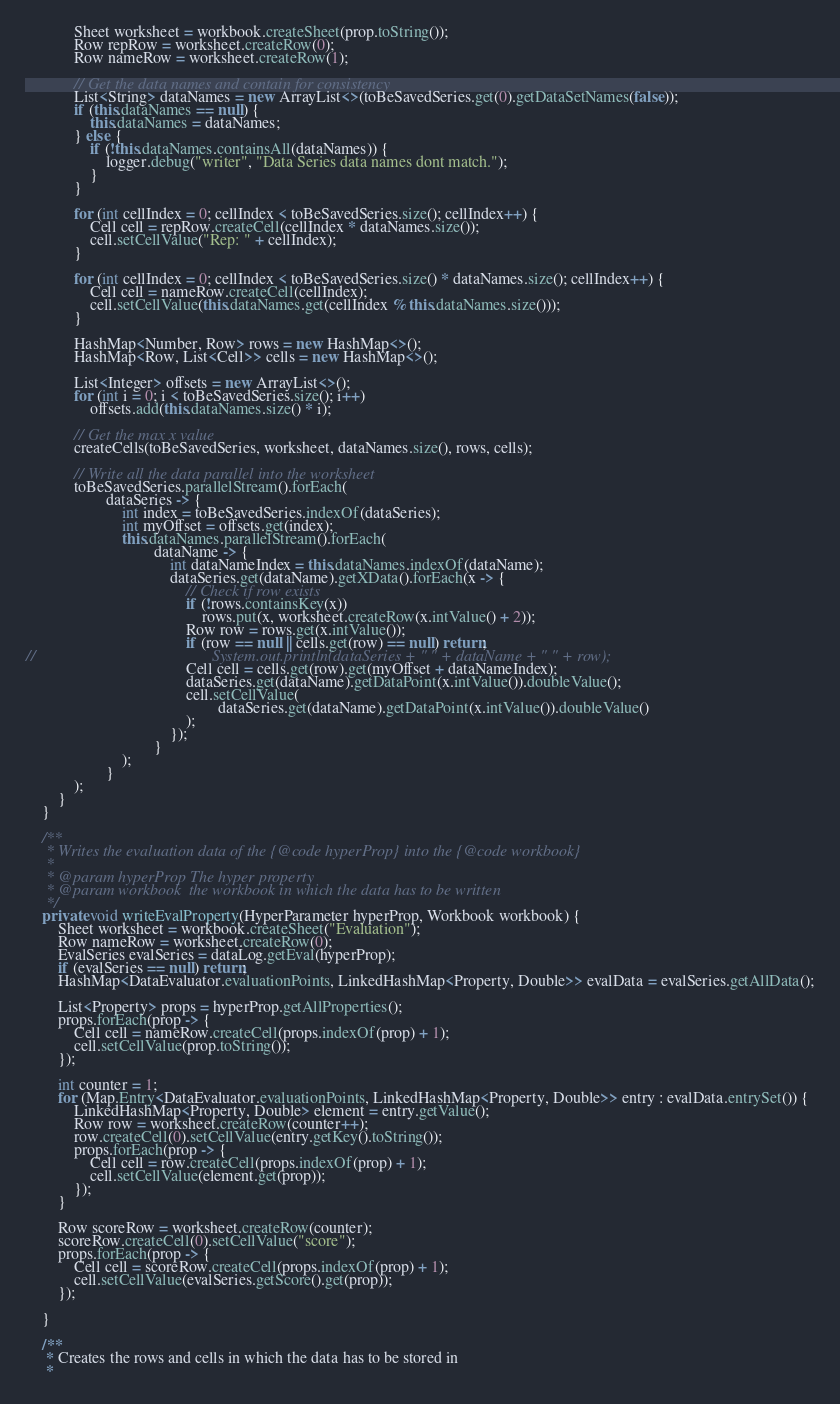Convert code to text. <code><loc_0><loc_0><loc_500><loc_500><_Java_>            Sheet worksheet = workbook.createSheet(prop.toString());
            Row repRow = worksheet.createRow(0);
            Row nameRow = worksheet.createRow(1);

            // Get the data names and contain for consistency
            List<String> dataNames = new ArrayList<>(toBeSavedSeries.get(0).getDataSetNames(false));
            if (this.dataNames == null) {
                this.dataNames = dataNames;
            } else {
                if (!this.dataNames.containsAll(dataNames)) {
                    logger.debug("writer", "Data Series data names dont match.");
                }
            }

            for (int cellIndex = 0; cellIndex < toBeSavedSeries.size(); cellIndex++) {
                Cell cell = repRow.createCell(cellIndex * dataNames.size());
                cell.setCellValue("Rep: " + cellIndex);
            }

            for (int cellIndex = 0; cellIndex < toBeSavedSeries.size() * dataNames.size(); cellIndex++) {
                Cell cell = nameRow.createCell(cellIndex);
                cell.setCellValue(this.dataNames.get(cellIndex % this.dataNames.size()));
            }

            HashMap<Number, Row> rows = new HashMap<>();
            HashMap<Row, List<Cell>> cells = new HashMap<>();

            List<Integer> offsets = new ArrayList<>();
            for (int i = 0; i < toBeSavedSeries.size(); i++)
                offsets.add(this.dataNames.size() * i);

            // Get the max x value
            createCells(toBeSavedSeries, worksheet, dataNames.size(), rows, cells);

            // Write all the data parallel into the worksheet
            toBeSavedSeries.parallelStream().forEach(
                    dataSeries -> {
                        int index = toBeSavedSeries.indexOf(dataSeries);
                        int myOffset = offsets.get(index);
                        this.dataNames.parallelStream().forEach(
                                dataName -> {
                                    int dataNameIndex = this.dataNames.indexOf(dataName);
                                    dataSeries.get(dataName).getXData().forEach(x -> {
                                        // Check if row exists
                                        if (!rows.containsKey(x))
                                            rows.put(x, worksheet.createRow(x.intValue() + 2));
                                        Row row = rows.get(x.intValue());
                                        if (row == null || cells.get(row) == null) return;
//                                            System.out.println(dataSeries + " " + dataName + " " + row);
                                        Cell cell = cells.get(row).get(myOffset + dataNameIndex);
                                        dataSeries.get(dataName).getDataPoint(x.intValue()).doubleValue();
                                        cell.setCellValue(
                                                dataSeries.get(dataName).getDataPoint(x.intValue()).doubleValue()
                                        );
                                    });
                                }
                        );
                    }
            );
        }
    }

    /**
     * Writes the evaluation data of the {@code hyperProp} into the {@code workbook}
     *
     * @param hyperProp The hyper property
     * @param workbook  the workbook in which the data has to be written
     */
    private void writeEvalProperty(HyperParameter hyperProp, Workbook workbook) {
        Sheet worksheet = workbook.createSheet("Evaluation");
        Row nameRow = worksheet.createRow(0);
        EvalSeries evalSeries = dataLog.getEval(hyperProp);
        if (evalSeries == null) return;
        HashMap<DataEvaluator.evaluationPoints, LinkedHashMap<Property, Double>> evalData = evalSeries.getAllData();

        List<Property> props = hyperProp.getAllProperties();
        props.forEach(prop -> {
            Cell cell = nameRow.createCell(props.indexOf(prop) + 1);
            cell.setCellValue(prop.toString());
        });

        int counter = 1;
        for (Map.Entry<DataEvaluator.evaluationPoints, LinkedHashMap<Property, Double>> entry : evalData.entrySet()) {
            LinkedHashMap<Property, Double> element = entry.getValue();
            Row row = worksheet.createRow(counter++);
            row.createCell(0).setCellValue(entry.getKey().toString());
            props.forEach(prop -> {
                Cell cell = row.createCell(props.indexOf(prop) + 1);
                cell.setCellValue(element.get(prop));
            });
        }

        Row scoreRow = worksheet.createRow(counter);
        scoreRow.createCell(0).setCellValue("score");
        props.forEach(prop -> {
            Cell cell = scoreRow.createCell(props.indexOf(prop) + 1);
            cell.setCellValue(evalSeries.getScore().get(prop));
        });

    }

    /**
     * Creates the rows and cells in which the data has to be stored in
     *</code> 